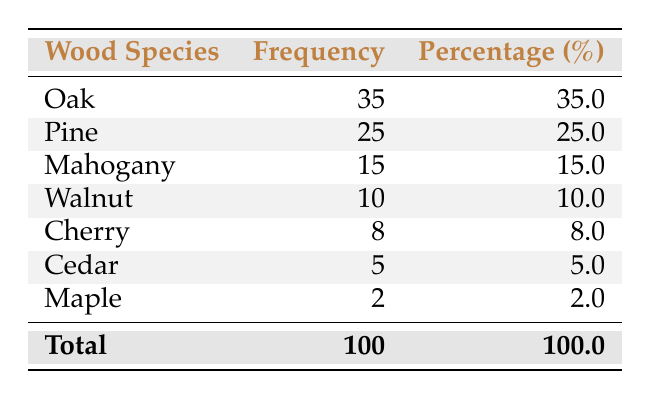What is the frequency of Oak wood used in construction? The table shows that the frequency for Oak wood is listed as 35.
Answer: 35 Which wood species has the lowest frequency? By examining the table, it shows that Maple has the lowest frequency at 2.
Answer: Maple What is the total frequency of all wood species listed? The total frequency is given in the last row of the table as 100, which sums the individual frequencies of all species.
Answer: 100 How many more instances of Pine are there compared to Walnut? Pine has a frequency of 25, while Walnut has a frequency of 10. The difference is 25 - 10 = 15.
Answer: 15 Is Cherry wood used more frequently than Cedar wood? Checking the table, Cherry wood has a frequency of 8 and Cedar wood has a frequency of 5. Since 8 is greater than 5, the statement is true.
Answer: Yes What percentage of the total does Mahogany represent? Mahogany has a frequency of 15 and the total frequency is 100. The percentage is calculated as (15/100) * 100 = 15.0%.
Answer: 15.0% What is the combined frequency of the top three wood species? The top three species are Oak (35), Pine (25), and Mahogany (15). Their combined frequency is 35 + 25 + 15 = 75.
Answer: 75 Is the frequency of Cedar wood at least 5% of the total wood frequency? Cedar has a frequency of 5. To find out if it is at least 5%, we calculate (5/100) * 100 = 5%, which matches the 5% threshold.
Answer: Yes If you were to rank the species by frequency, what would be the rank of Cherry? The frequency rankings from highest to lowest are: Oak (1), Pine (2), Mahogany (3), Walnut (4), Cherry (5), Cedar (6), and Maple (7). Cherry ranks 5th.
Answer: 5th 